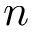Convert formula to latex. <formula><loc_0><loc_0><loc_500><loc_500>n</formula> 